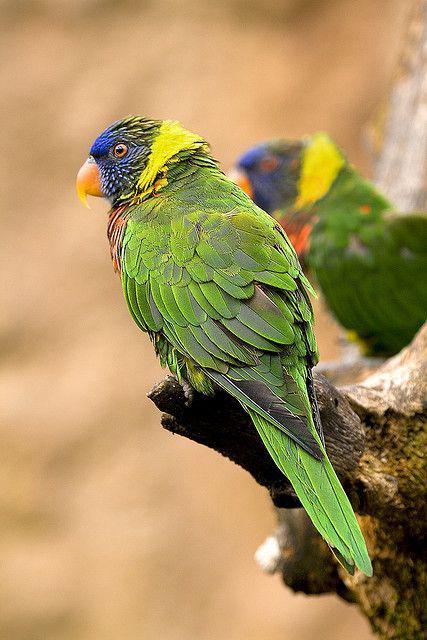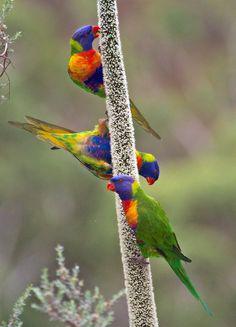The first image is the image on the left, the second image is the image on the right. Considering the images on both sides, is "The right and left images contain the same number of parrots." valid? Answer yes or no. No. The first image is the image on the left, the second image is the image on the right. Considering the images on both sides, is "There are no more than three birds" valid? Answer yes or no. No. 